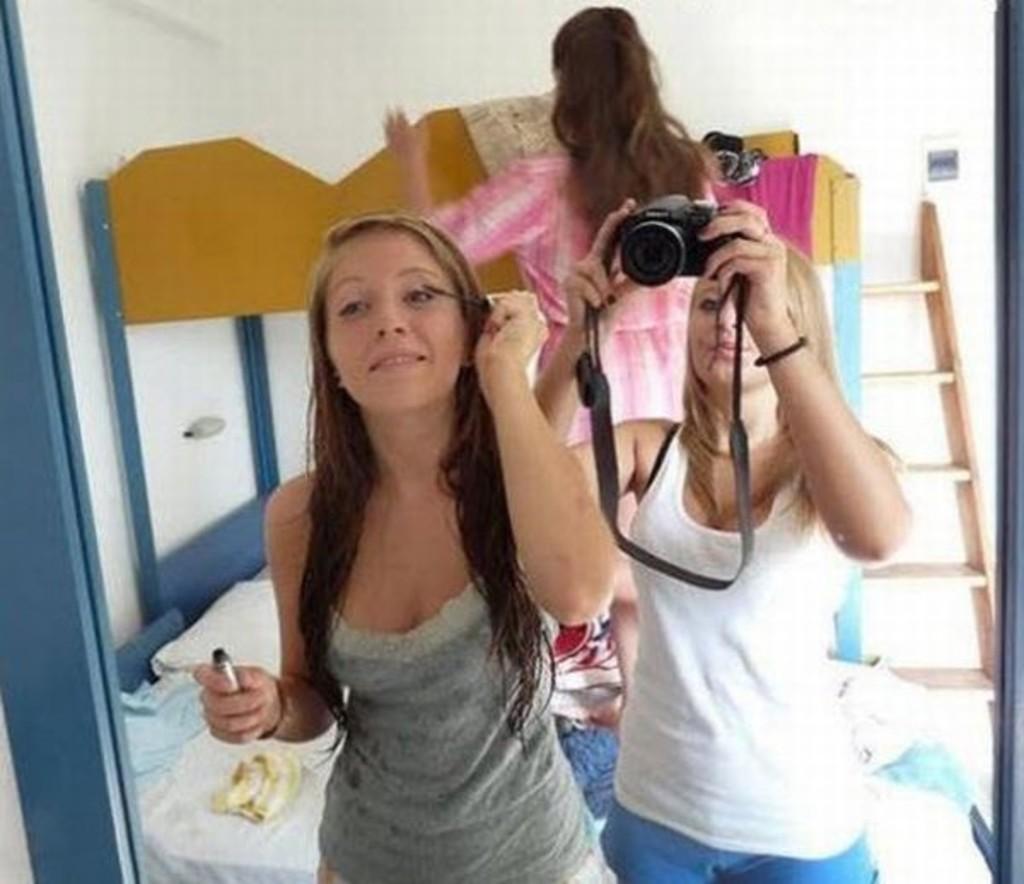Describe this image in one or two sentences. In this image i can see inside view of home and there is a bed attached to the wall,there are some clothes on the bed. In the middle of the image there are the two persons standing ,one person on the left side she is wearing a gray color shirt and she is holding a mascara on his hand and beside her another woman wearing white shirt and she holding a camera on her hand. on the right side there is a ladder attached to the wall. and there is a another woman back side of her wearing a pink color skirt. 